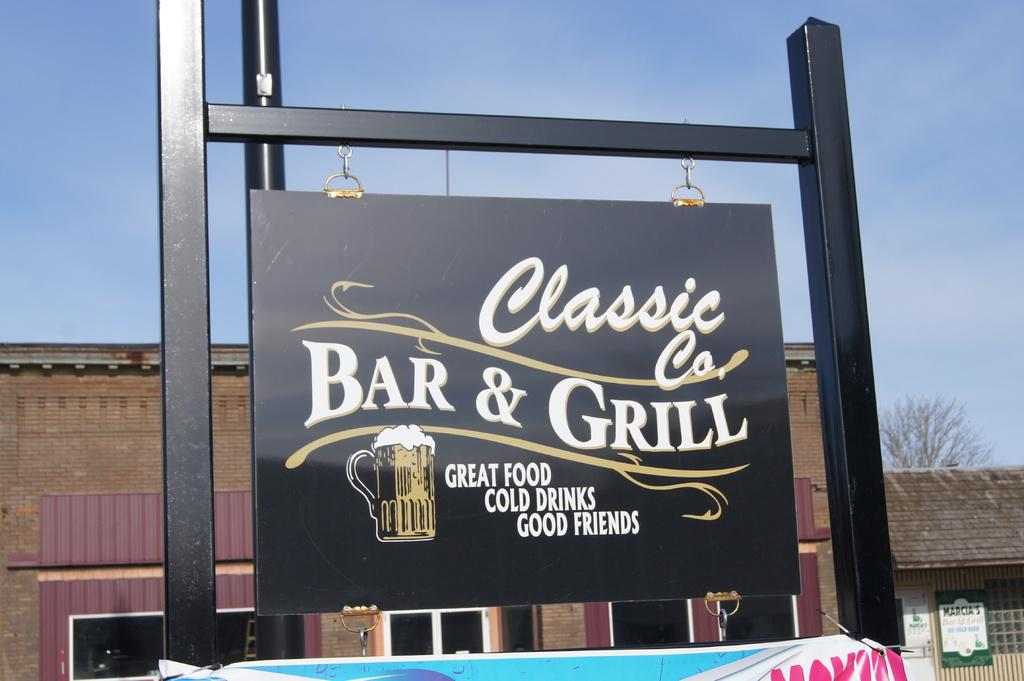Provide a one-sentence caption for the provided image. A signpost that says Classic Co's Bar & Grill, displayed in front of a building. 